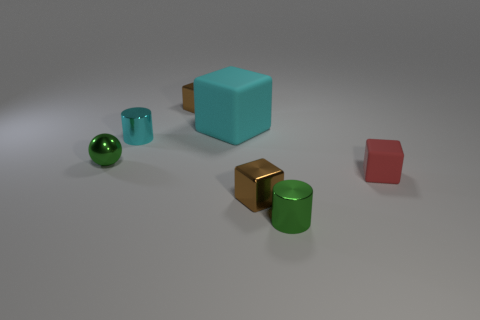Subtract all brown spheres. How many brown blocks are left? 2 Subtract all tiny red blocks. How many blocks are left? 3 Subtract all cyan cubes. How many cubes are left? 3 Subtract all green cubes. Subtract all green cylinders. How many cubes are left? 4 Add 1 yellow shiny cylinders. How many objects exist? 8 Subtract all cylinders. How many objects are left? 5 Subtract all small shiny objects. Subtract all green objects. How many objects are left? 0 Add 2 metallic cubes. How many metallic cubes are left? 4 Add 3 tiny cyan cylinders. How many tiny cyan cylinders exist? 4 Subtract 0 blue spheres. How many objects are left? 7 